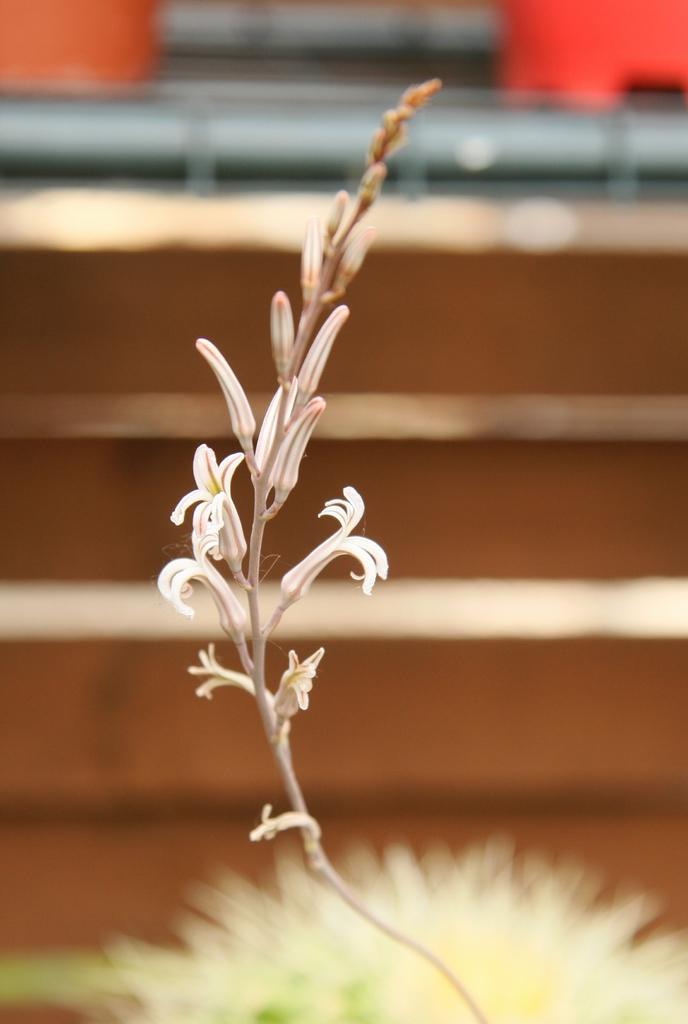Could you give a brief overview of what you see in this image? In this image we can see few flowers and buds. The background of the image is blurred. 